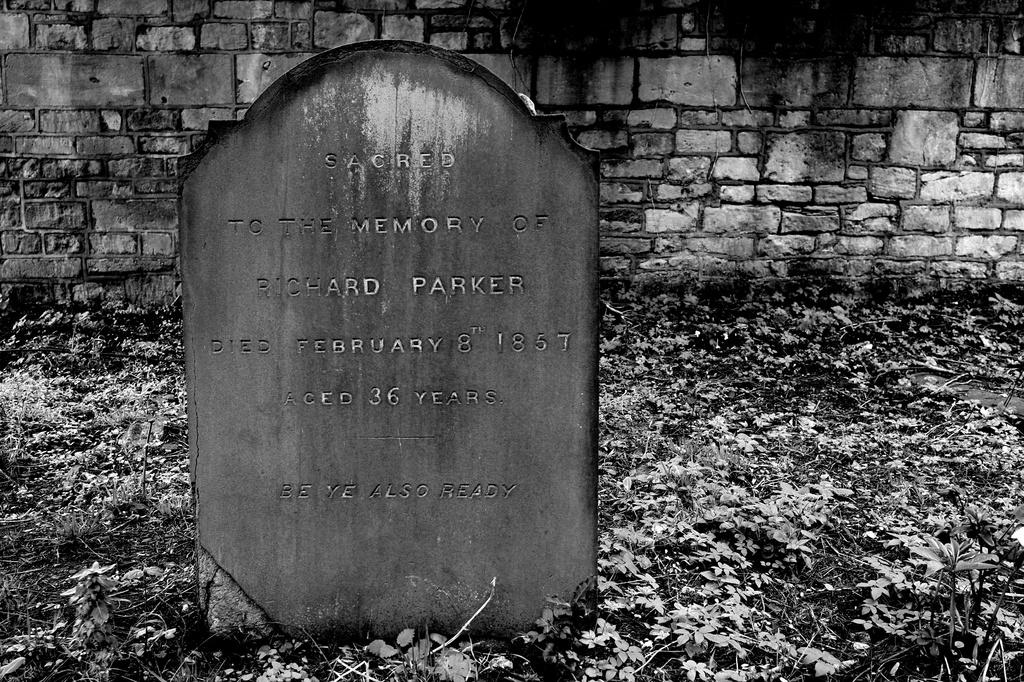What is the color scheme of the image? The image is black and white. What can be seen on the stone in the image? There is a lay stone with text in the image. What is visible in the background of the image? There is a wall in the background of the image. What type of vegetation is present on the ground in the image? Leaves are present on the ground at the bottom of the image. What type of plastic sign can be seen in the image? There is no plastic sign present in the image. What color is the flag in the image? There is no flag present in the image. 